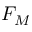<formula> <loc_0><loc_0><loc_500><loc_500>F _ { M }</formula> 